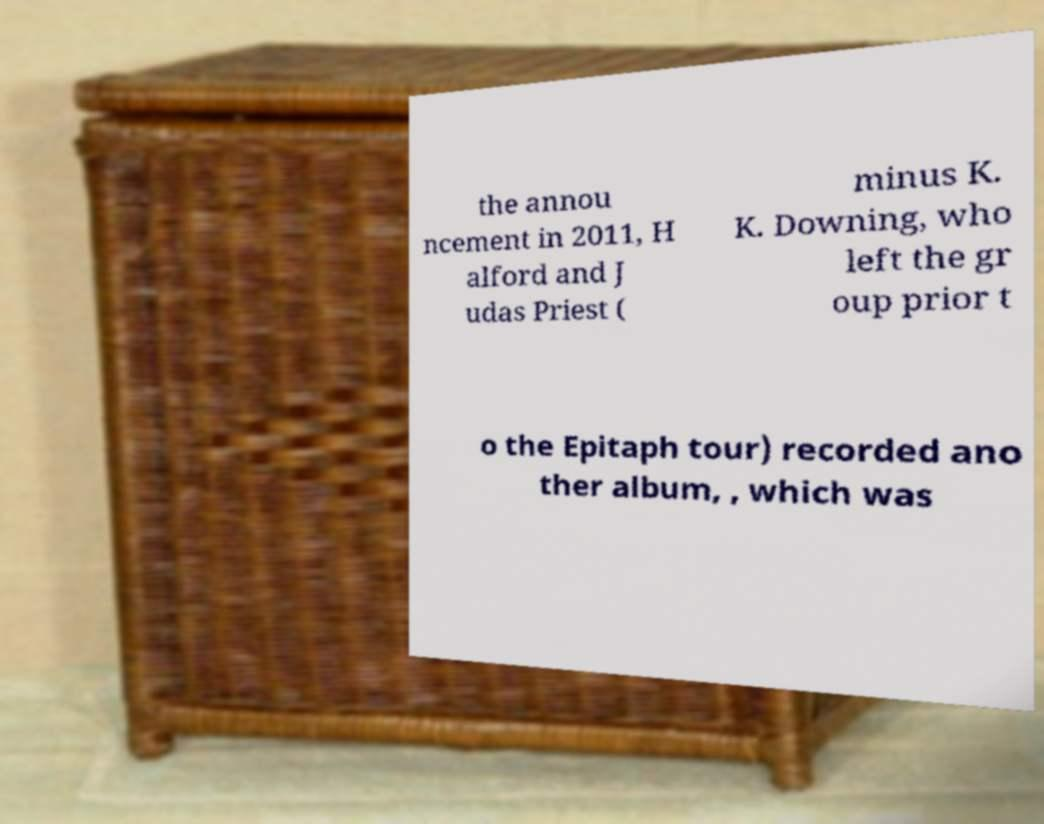Could you extract and type out the text from this image? the annou ncement in 2011, H alford and J udas Priest ( minus K. K. Downing, who left the gr oup prior t o the Epitaph tour) recorded ano ther album, , which was 